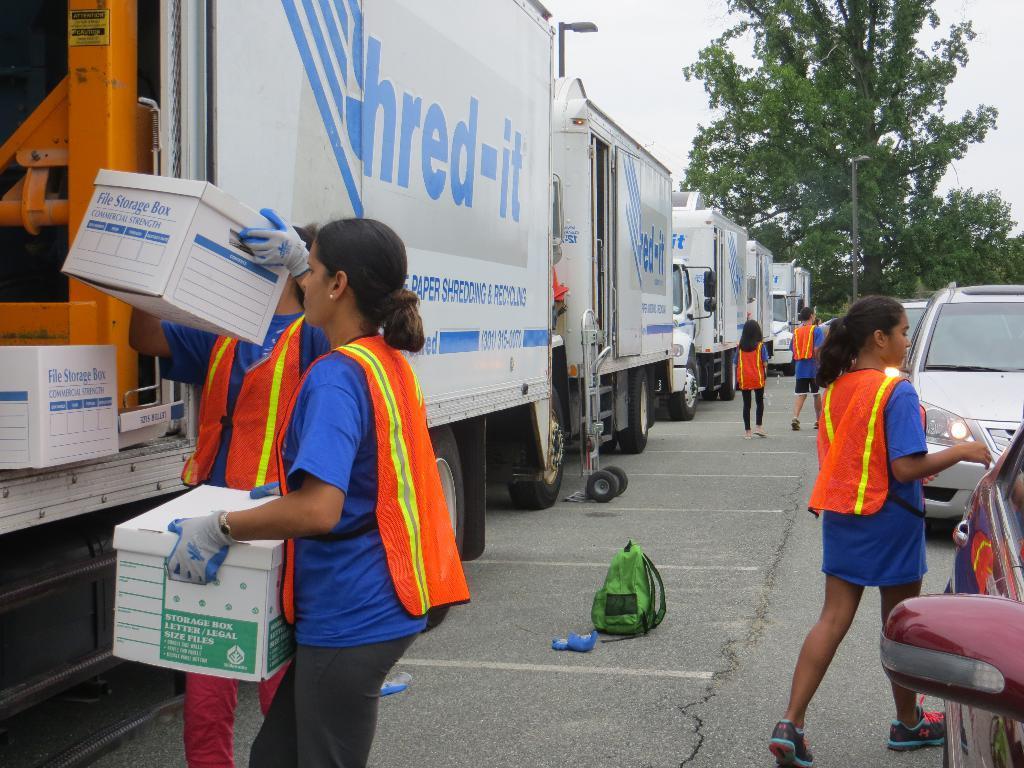In one or two sentences, can you explain what this image depicts? There is a road. On the left side, we can see white color trucks, on the tracks we can see thread it. Two women are loading some storage boxes. On the right side, we can see cars and one lady is standing at the right side and two women are walking. In the middle one green color bag is there. 